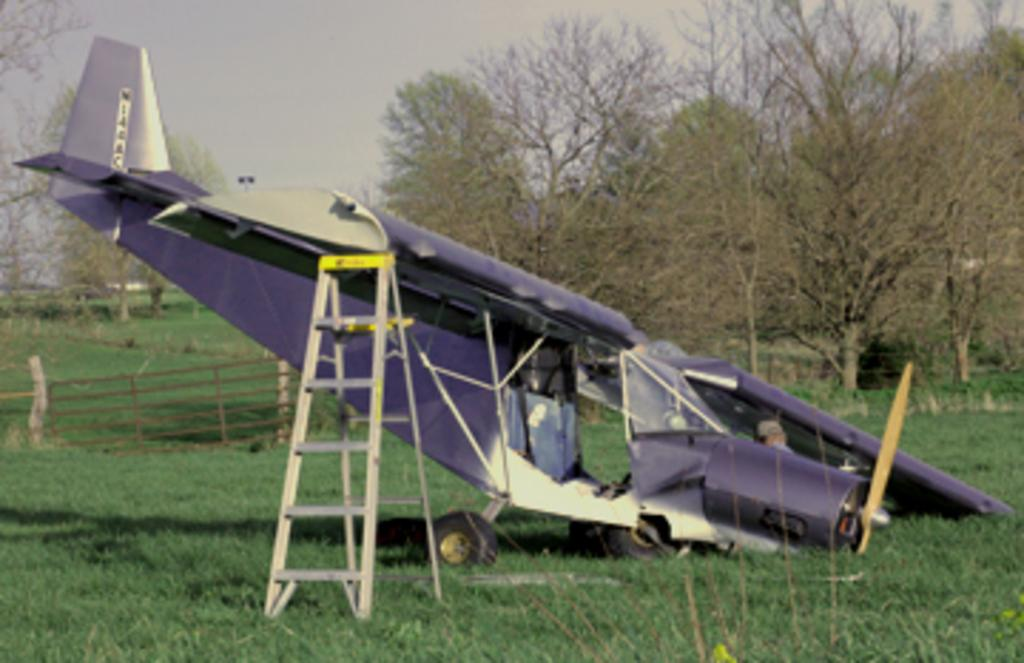What is the main subject of the image? The main subject of the image is an aeroplane. What can be seen in the background of the image? In the background of the image, there is a wooden fence, trees, grass, an extendable ladder, and the sky. What type of bell can be heard ringing in the image? There is no bell present in the image, and therefore no sound can be heard. How many heads are visible in the image? There is no head visible in the image; it features an aeroplane and various elements in the background. 